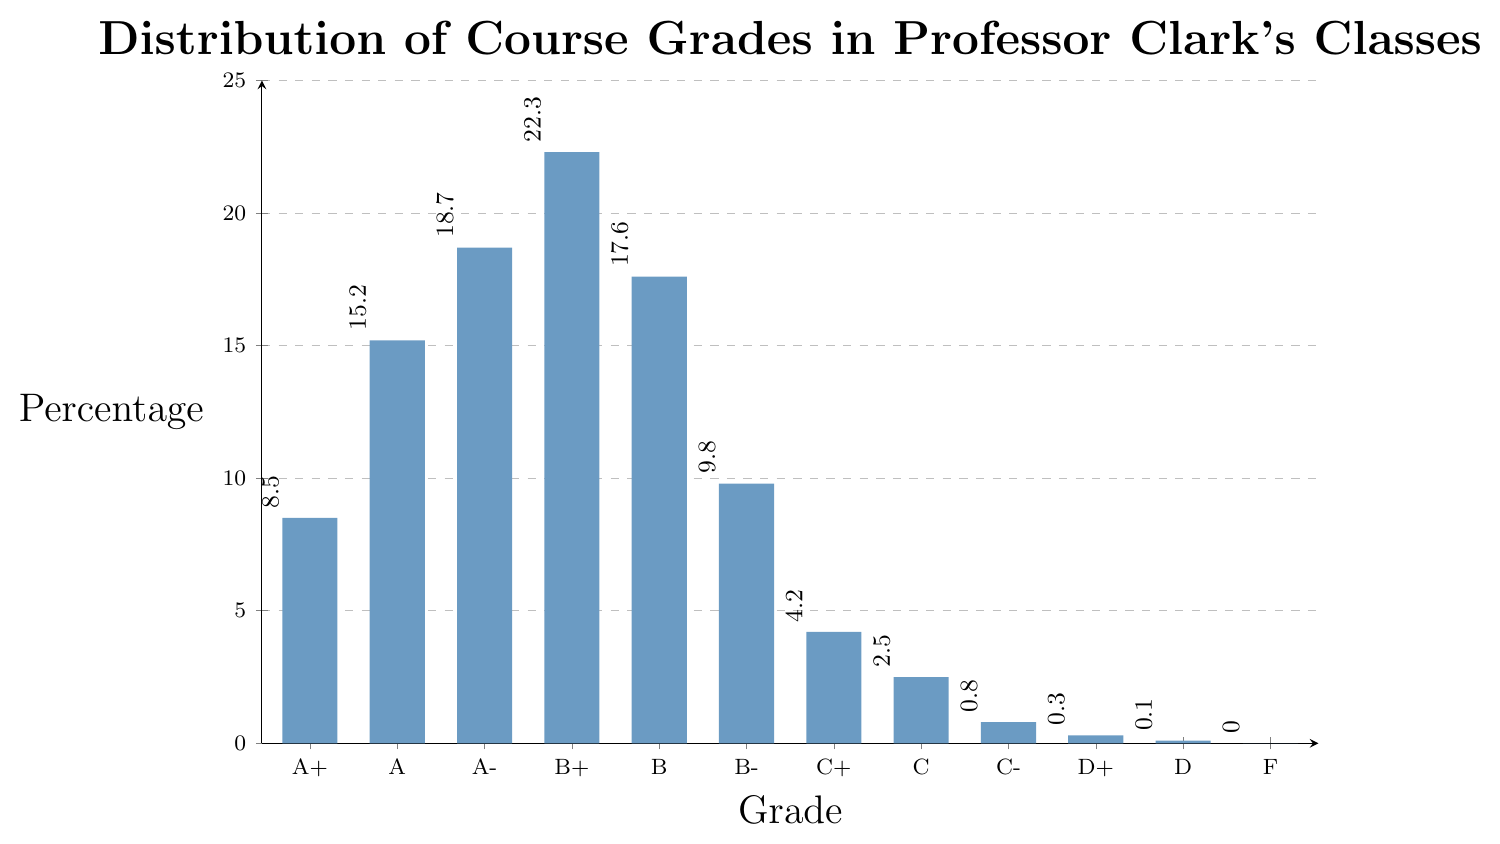what is the total percentage of grades in the B range (B+, B, B-)? To find the total percentage of grades in the B range, sum the percentages for B+ (22.3%), B (17.6%), and B- (9.8%). 22.3 + 17.6 + 9.8 = 49.7%
Answer: 49.7% Which grade has the highest percentage? Looking at the heights of the bars, the grade with the highest bar is B+, indicating it has the highest percentage of 22.3%
Answer: B+ How does the percentage of A (15.2%) compare to the percentage of A+ (8.5%)? The percentage of A (15.2%) is greater than the percentage of A+ (8.5%), which can be seen by comparing the heights of the respective bars
Answer: A is greater than A+ What is the percentage difference between the A- and C grades? Subtract the percentage of C (2.5%) from the percentage of A- (18.7%) to find the difference: 18.7 - 2.5 = 16.2%
Answer: 16.2% What is the average percentage of grades that fall in the C range (C+, C, C-)? Sum the percentages of C+ (4.2%), C (2.5%), and C- (0.8%) and divide by 3: (4.2 + 2.5 + 0.8)/3 = 7.5/3 = 2.5%
Answer: 2.5% How many grades are there with a percentage less than 1%? The grades with percentages less than 1% are C- (0.8%), D+ (0.3%), and D (0.1%). There are three such grades.
Answer: 3 What is the percentage range (difference between highest and lowest) for all grades? The highest percentage is for B+ (22.3%) and the lowest (excluding F) is D (0.1%). The range is 22.3 - 0.1 = 22.2%
Answer: 22.2% Which grades have a percentage of exactly 0%? From the plot, the grade F has a percentage of exactly 0%
Answer: F 